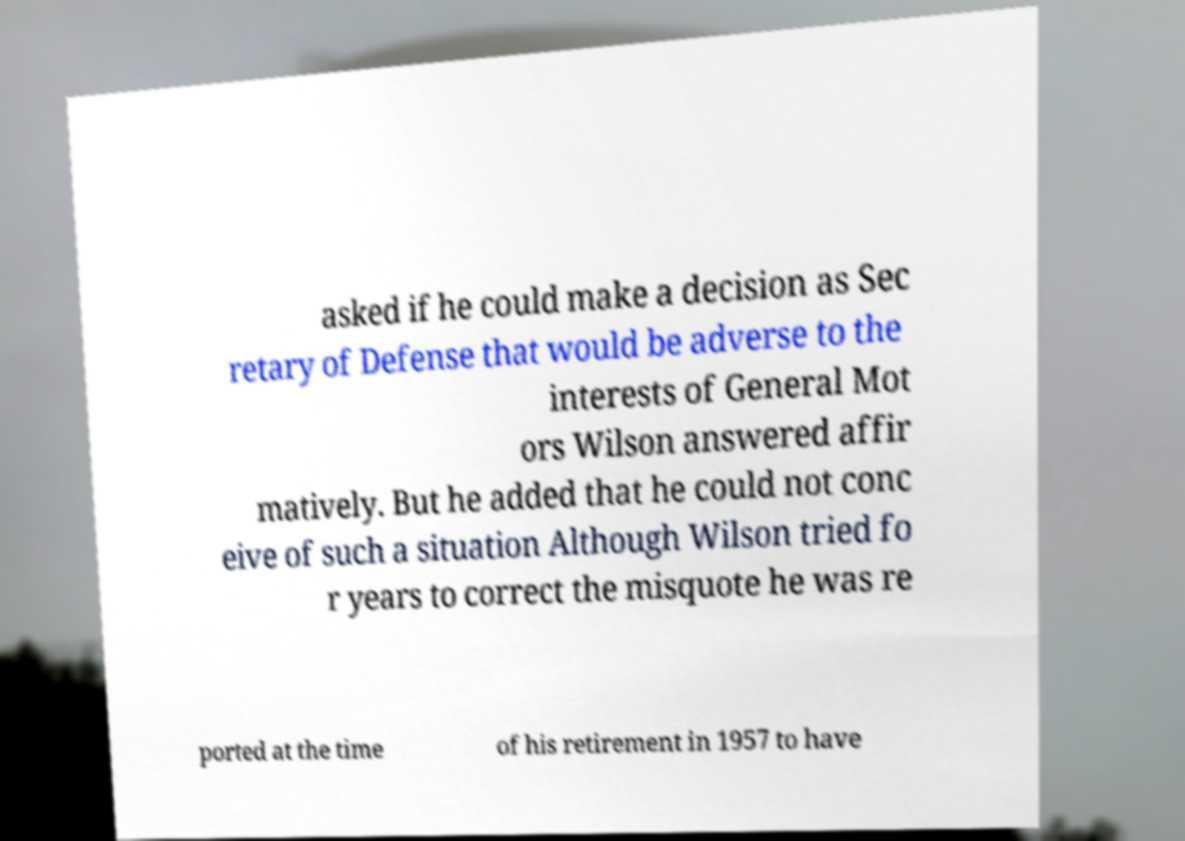Can you accurately transcribe the text from the provided image for me? asked if he could make a decision as Sec retary of Defense that would be adverse to the interests of General Mot ors Wilson answered affir matively. But he added that he could not conc eive of such a situation Although Wilson tried fo r years to correct the misquote he was re ported at the time of his retirement in 1957 to have 